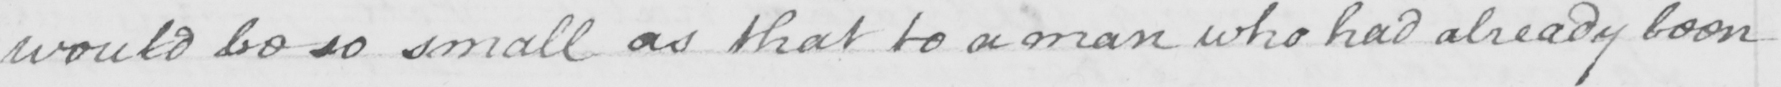Transcribe the text shown in this historical manuscript line. would be so small as that to a man who had already been 